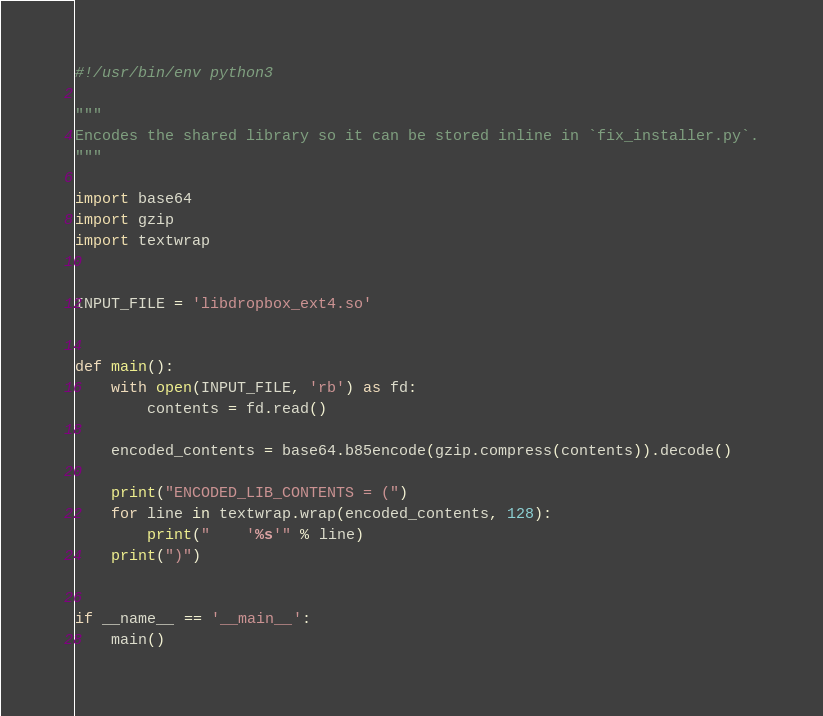<code> <loc_0><loc_0><loc_500><loc_500><_Python_>#!/usr/bin/env python3

"""
Encodes the shared library so it can be stored inline in `fix_installer.py`.
"""

import base64
import gzip
import textwrap


INPUT_FILE = 'libdropbox_ext4.so'


def main():
    with open(INPUT_FILE, 'rb') as fd:
        contents = fd.read()

    encoded_contents = base64.b85encode(gzip.compress(contents)).decode()

    print("ENCODED_LIB_CONTENTS = (")
    for line in textwrap.wrap(encoded_contents, 128):
        print("    '%s'" % line)
    print(")")


if __name__ == '__main__':
    main()
</code> 